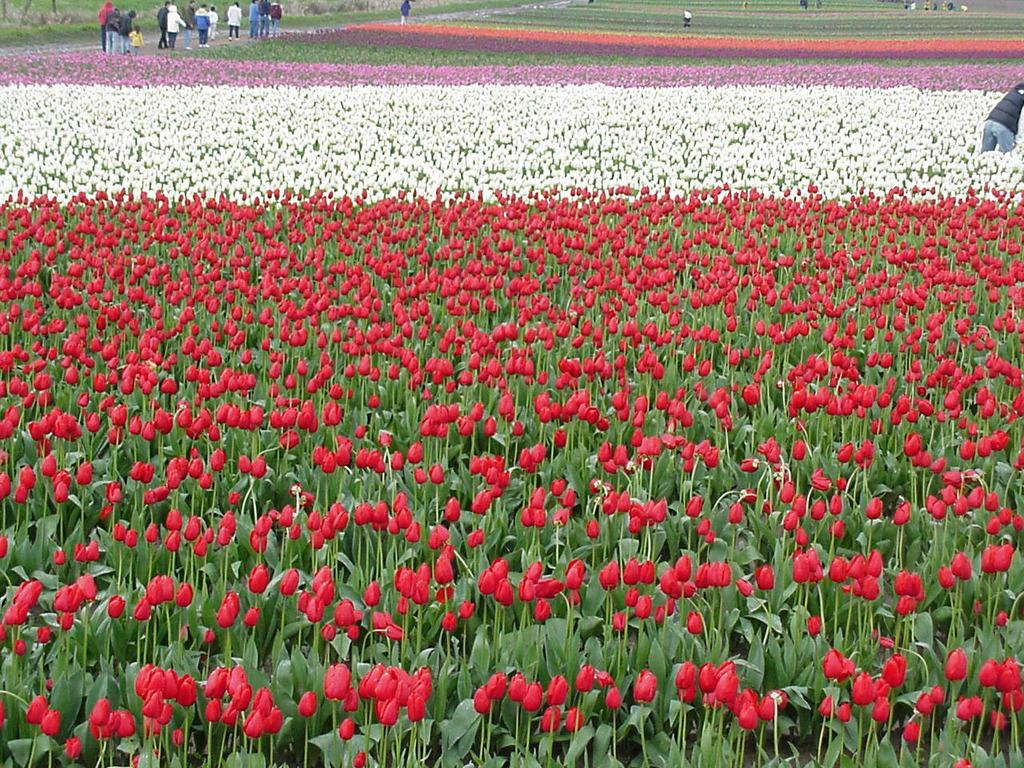What is the main subject of the image? The main subject of the image is a flower field. Are there any people visible in the image? Yes, there are people at the top side of the image. What type of window can be seen in the flower field? There is no window present in the flower field; it is an outdoor scene with a field of flowers. 